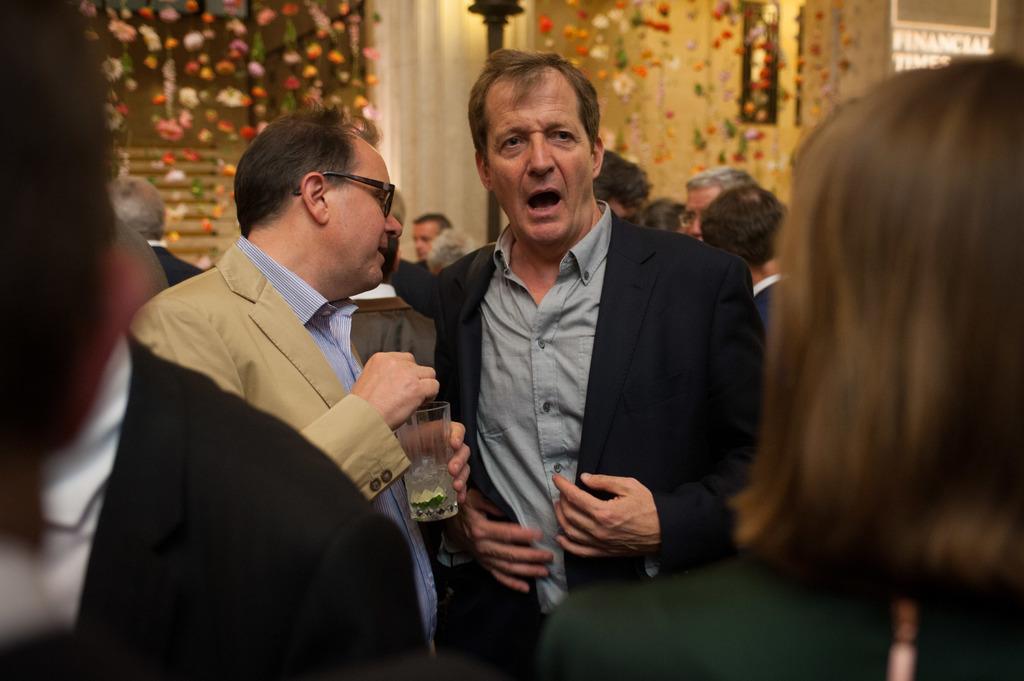Please provide a concise description of this image. In the foreground of this image, there is a woman and a man. In the middle, there are two men standing where a man is holding a glass. In the background, there are people standing, a light pole, pillar, flowers hanging and the wall. 